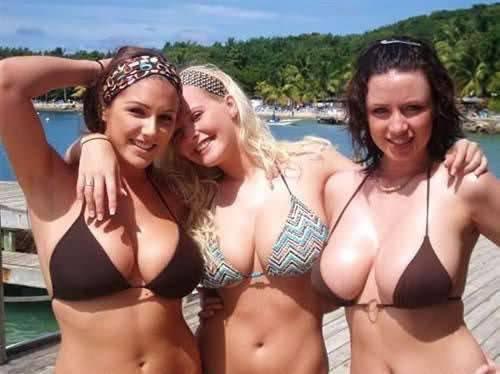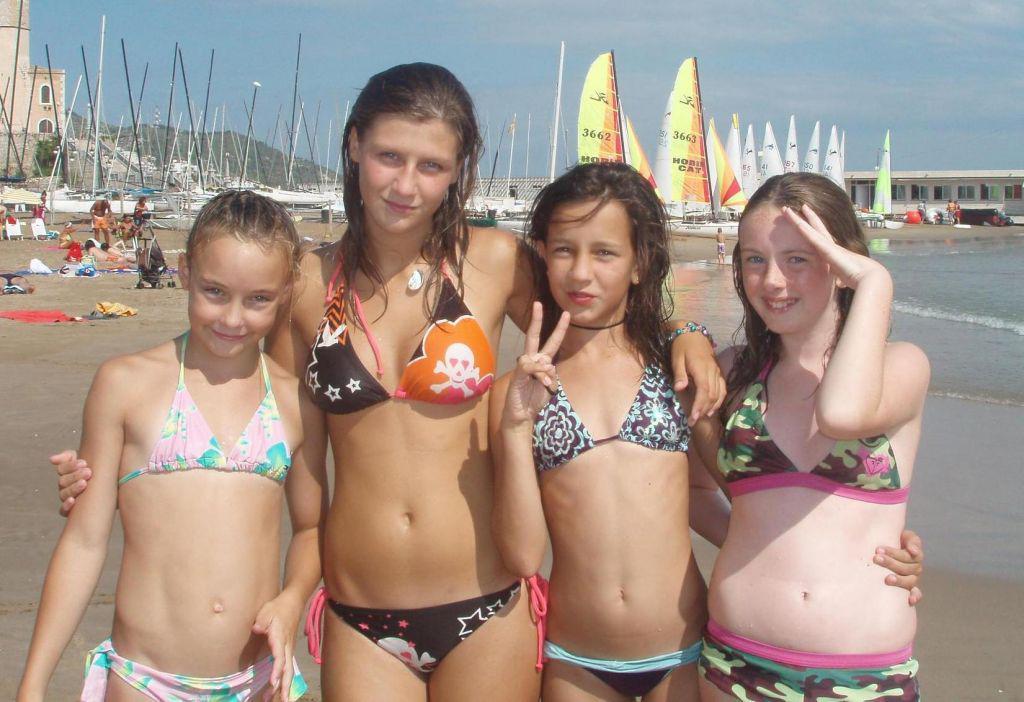The first image is the image on the left, the second image is the image on the right. Considering the images on both sides, is "There are seven girls." valid? Answer yes or no. Yes. The first image is the image on the left, the second image is the image on the right. For the images displayed, is the sentence "There are four girls wearing swimsuits at the beach in one of the images." factually correct? Answer yes or no. Yes. 